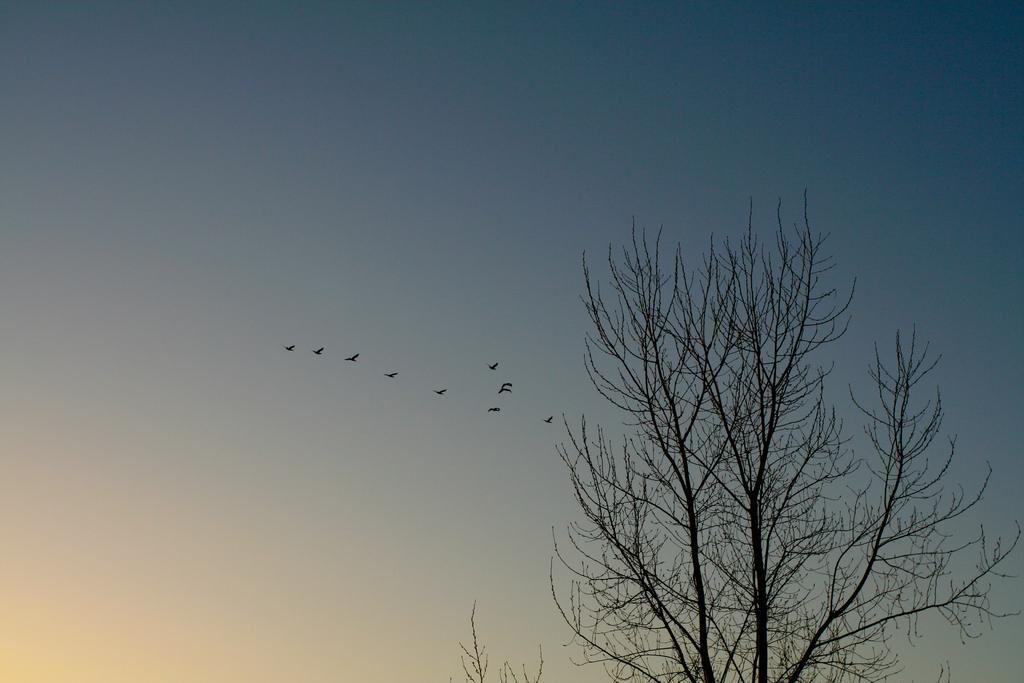What type of vegetation is on the right side of the image? There are trees on the right side of the image. What is happening in the sky in the middle of the image? There are birds flying in the sky in the middle of the image. How many beds can be seen in the image? There are no beds present in the image. What type of bird is flying in the image? The provided facts do not specify the type of bird flying in the image. 